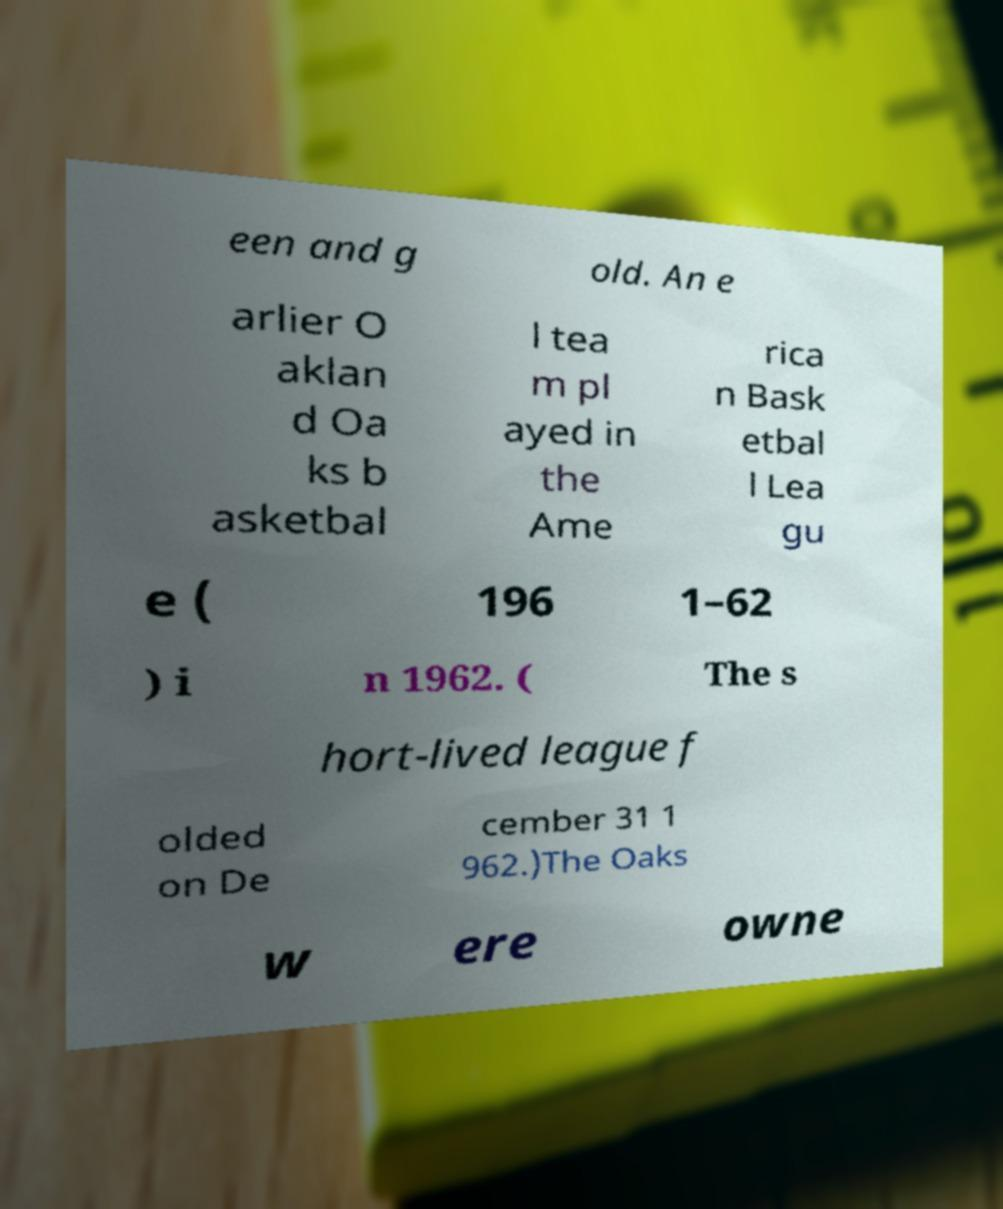Can you accurately transcribe the text from the provided image for me? een and g old. An e arlier O aklan d Oa ks b asketbal l tea m pl ayed in the Ame rica n Bask etbal l Lea gu e ( 196 1–62 ) i n 1962. ( The s hort-lived league f olded on De cember 31 1 962.)The Oaks w ere owne 